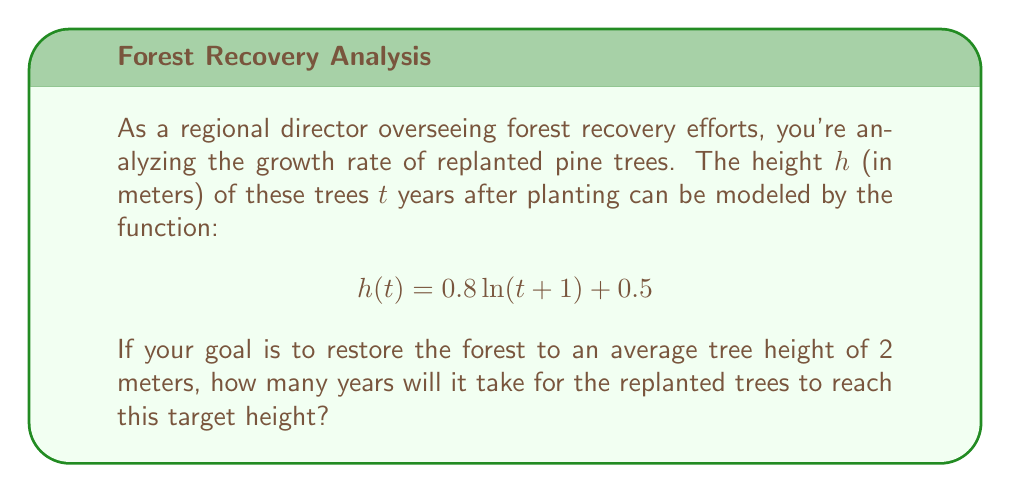Solve this math problem. To solve this problem, we need to find the value of $t$ when $h(t) = 2$. Let's approach this step-by-step:

1) We start with the equation:
   $$h(t) = 0.8 \ln(t+1) + 0.5$$

2) We want to find $t$ when $h(t) = 2$, so we set up the equation:
   $$2 = 0.8 \ln(t+1) + 0.5$$

3) Subtract 0.5 from both sides:
   $$1.5 = 0.8 \ln(t+1)$$

4) Divide both sides by 0.8:
   $$\frac{1.5}{0.8} = \ln(t+1)$$
   $$1.875 = \ln(t+1)$$

5) To isolate $t$, we need to apply the exponential function (e^) to both sides:
   $$e^{1.875} = e^{\ln(t+1)}$$
   $$e^{1.875} = t+1$$

6) Subtract 1 from both sides:
   $$e^{1.875} - 1 = t$$

7) Calculate the value:
   $$t \approx 5.52$$

8) Since we can't plant partial trees, we need to round up to the nearest whole year.
Answer: 6 years 